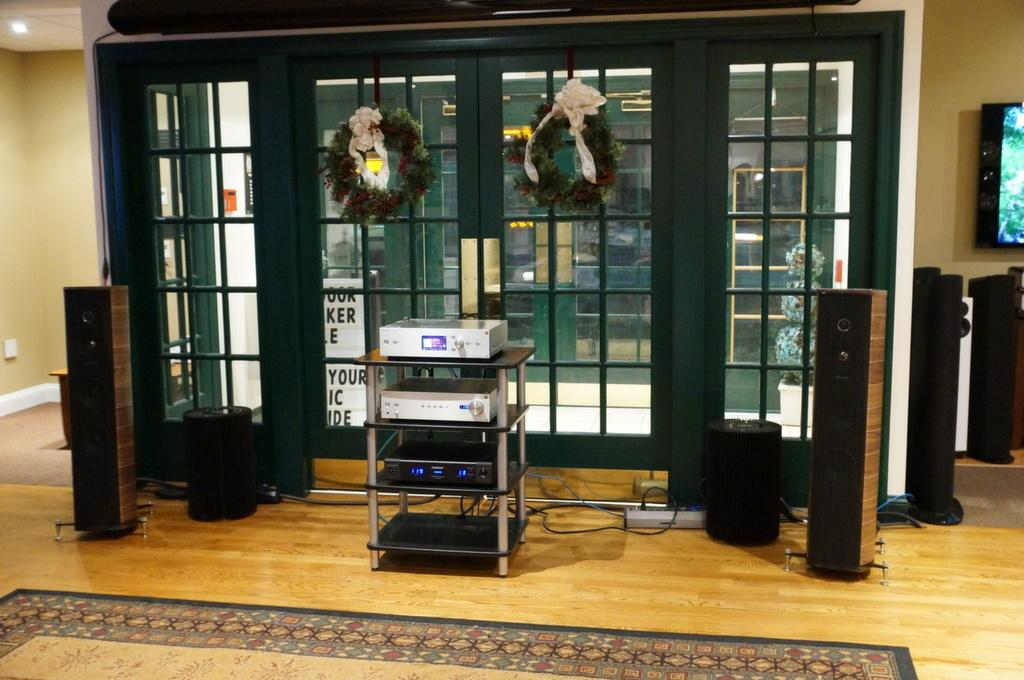What is located in the foreground of the image? There is a table in the foreground of the image, along with a DVD player and speakers. What can be seen in the background of the image? In the background of the image, there is a wall, windows, garlands, and a TV. What type of room is the image taken in? The image is taken in a hall. What type of wood is used to make the desk in the image? There is no desk present in the image. How many wings are visible on the bird in the image? There are no birds or wings present in the image. 